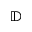Convert formula to latex. <formula><loc_0><loc_0><loc_500><loc_500>\mathbb { D }</formula> 